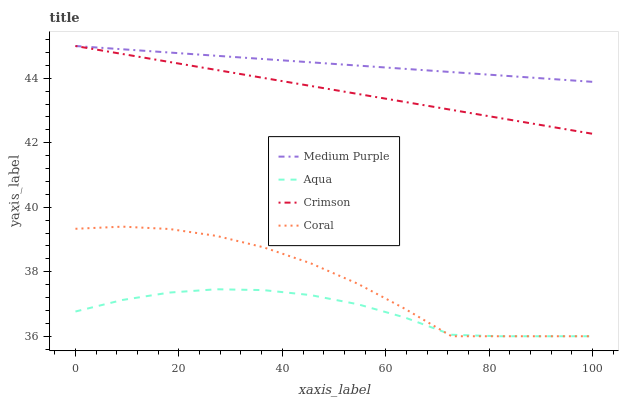Does Aqua have the minimum area under the curve?
Answer yes or no. Yes. Does Medium Purple have the maximum area under the curve?
Answer yes or no. Yes. Does Crimson have the minimum area under the curve?
Answer yes or no. No. Does Crimson have the maximum area under the curve?
Answer yes or no. No. Is Crimson the smoothest?
Answer yes or no. Yes. Is Coral the roughest?
Answer yes or no. Yes. Is Coral the smoothest?
Answer yes or no. No. Is Crimson the roughest?
Answer yes or no. No. Does Coral have the lowest value?
Answer yes or no. Yes. Does Crimson have the lowest value?
Answer yes or no. No. Does Crimson have the highest value?
Answer yes or no. Yes. Does Coral have the highest value?
Answer yes or no. No. Is Coral less than Medium Purple?
Answer yes or no. Yes. Is Crimson greater than Coral?
Answer yes or no. Yes. Does Crimson intersect Medium Purple?
Answer yes or no. Yes. Is Crimson less than Medium Purple?
Answer yes or no. No. Is Crimson greater than Medium Purple?
Answer yes or no. No. Does Coral intersect Medium Purple?
Answer yes or no. No. 